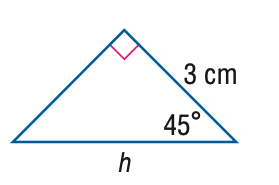Question: Find h in the triangle.
Choices:
A. 3 \sqrt 2
B. 3 \sqrt 3
C. 6
D. 6 \sqrt 2
Answer with the letter. Answer: A 